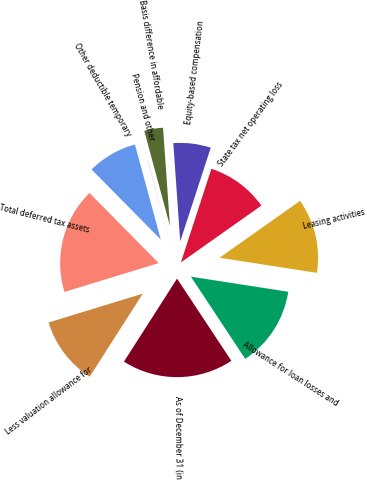Convert chart. <chart><loc_0><loc_0><loc_500><loc_500><pie_chart><fcel>As of December 31 (in<fcel>Allowance for loan losses and<fcel>Leasing activities<fcel>State tax net operating loss<fcel>Equity-based compensation<fcel>Basis difference in affordable<fcel>Pension and other<fcel>Other deductible temporary<fcel>Total deferred tax assets<fcel>Less valuation allowance for<nl><fcel>18.35%<fcel>13.26%<fcel>12.24%<fcel>10.2%<fcel>6.13%<fcel>3.08%<fcel>0.03%<fcel>8.17%<fcel>17.33%<fcel>11.22%<nl></chart> 